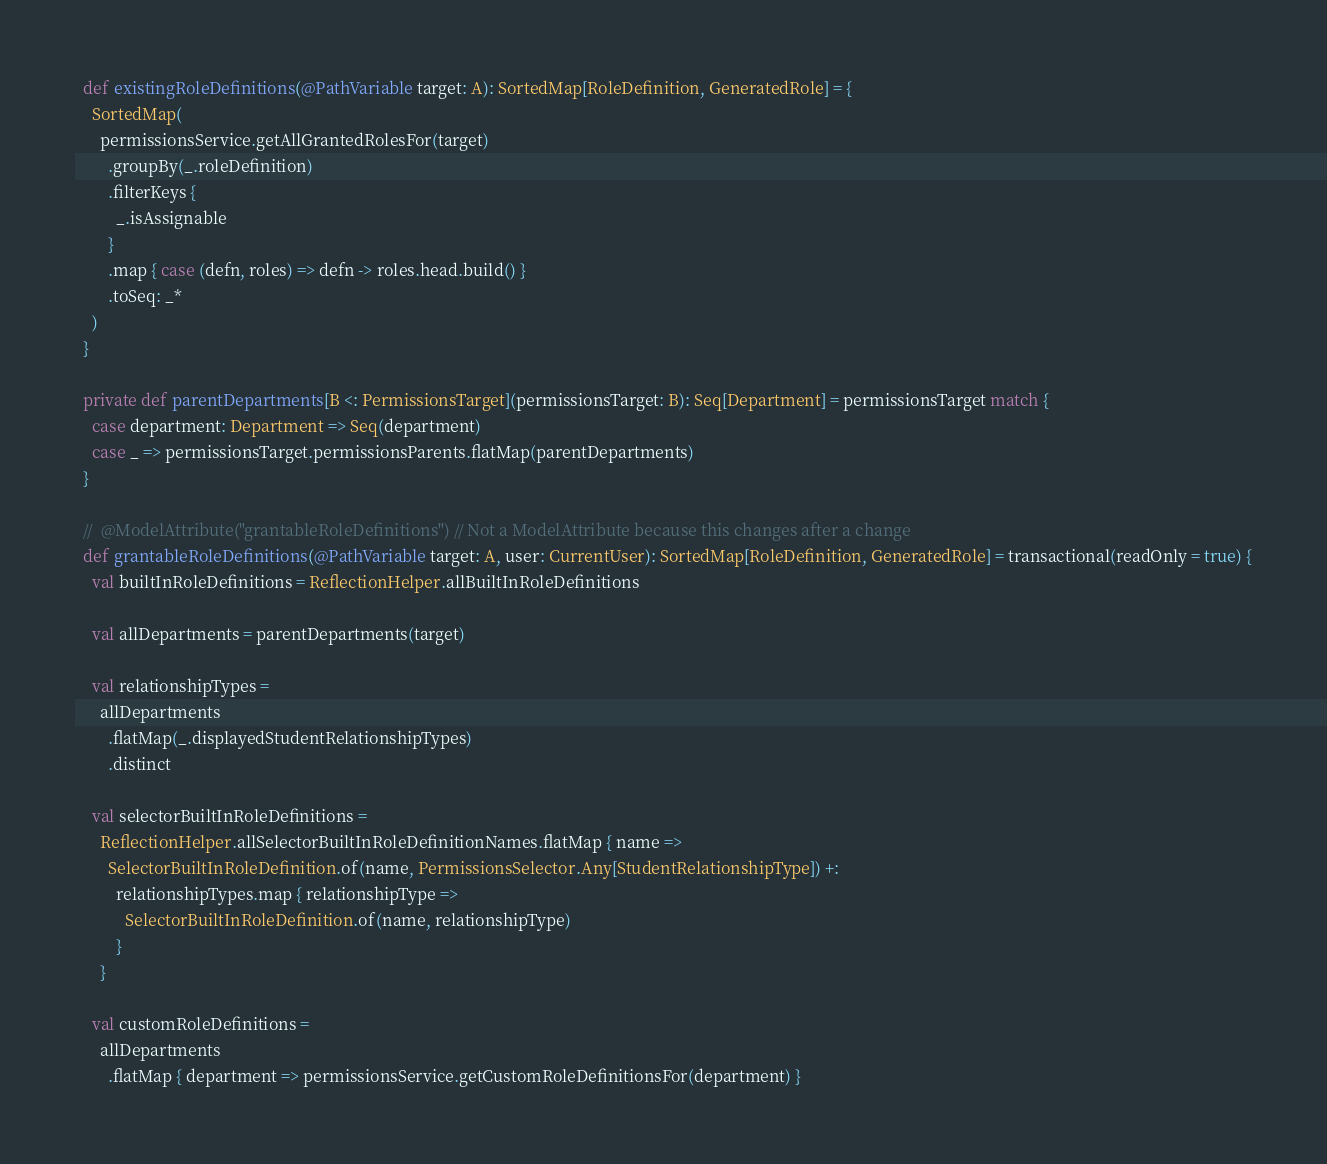<code> <loc_0><loc_0><loc_500><loc_500><_Scala_>  def existingRoleDefinitions(@PathVariable target: A): SortedMap[RoleDefinition, GeneratedRole] = {
    SortedMap(
      permissionsService.getAllGrantedRolesFor(target)
        .groupBy(_.roleDefinition)
        .filterKeys {
          _.isAssignable
        }
        .map { case (defn, roles) => defn -> roles.head.build() }
        .toSeq: _*
    )
  }

  private def parentDepartments[B <: PermissionsTarget](permissionsTarget: B): Seq[Department] = permissionsTarget match {
    case department: Department => Seq(department)
    case _ => permissionsTarget.permissionsParents.flatMap(parentDepartments)
  }

  //	@ModelAttribute("grantableRoleDefinitions") // Not a ModelAttribute because this changes after a change
  def grantableRoleDefinitions(@PathVariable target: A, user: CurrentUser): SortedMap[RoleDefinition, GeneratedRole] = transactional(readOnly = true) {
    val builtInRoleDefinitions = ReflectionHelper.allBuiltInRoleDefinitions

    val allDepartments = parentDepartments(target)

    val relationshipTypes =
      allDepartments
        .flatMap(_.displayedStudentRelationshipTypes)
        .distinct

    val selectorBuiltInRoleDefinitions =
      ReflectionHelper.allSelectorBuiltInRoleDefinitionNames.flatMap { name =>
        SelectorBuiltInRoleDefinition.of(name, PermissionsSelector.Any[StudentRelationshipType]) +:
          relationshipTypes.map { relationshipType =>
            SelectorBuiltInRoleDefinition.of(name, relationshipType)
          }
      }

    val customRoleDefinitions =
      allDepartments
        .flatMap { department => permissionsService.getCustomRoleDefinitionsFor(department) }</code> 